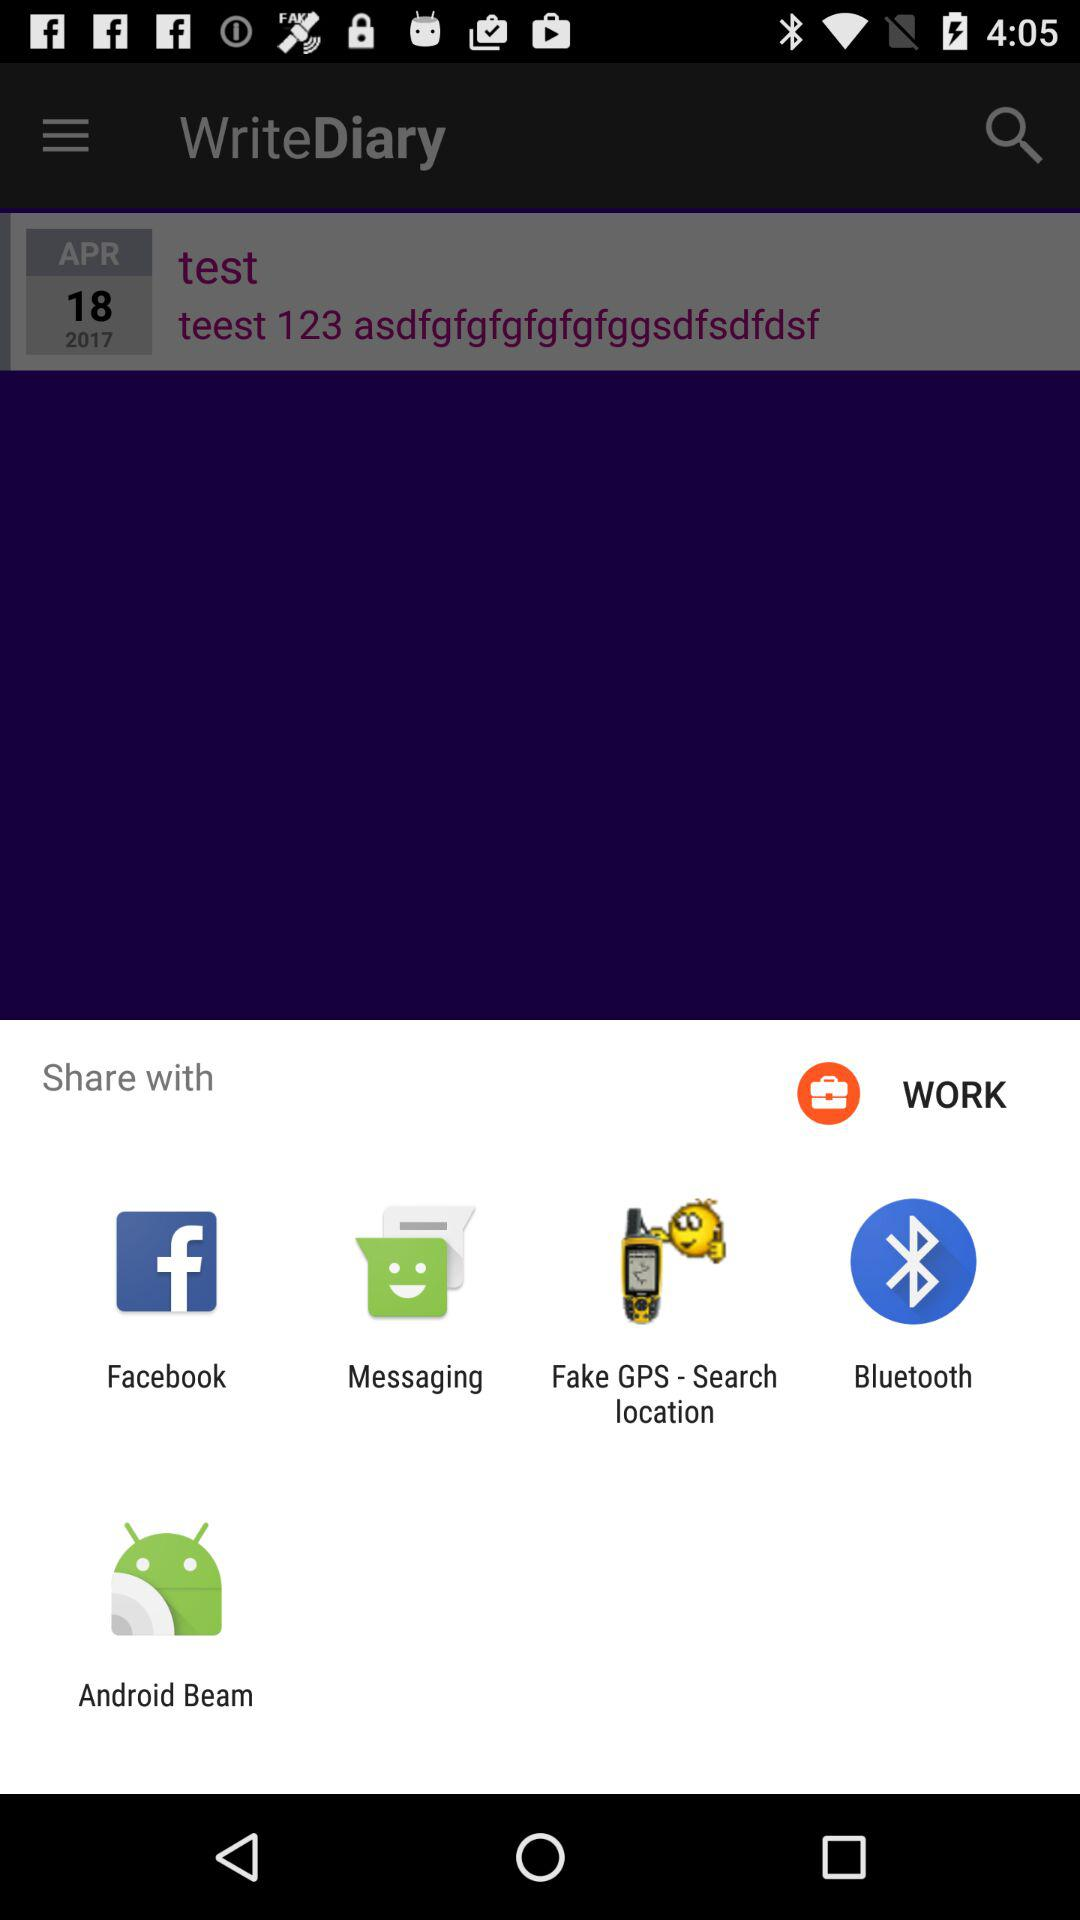Which date is mentioned on the calendar? The mentioned date is April 18, 2017. 